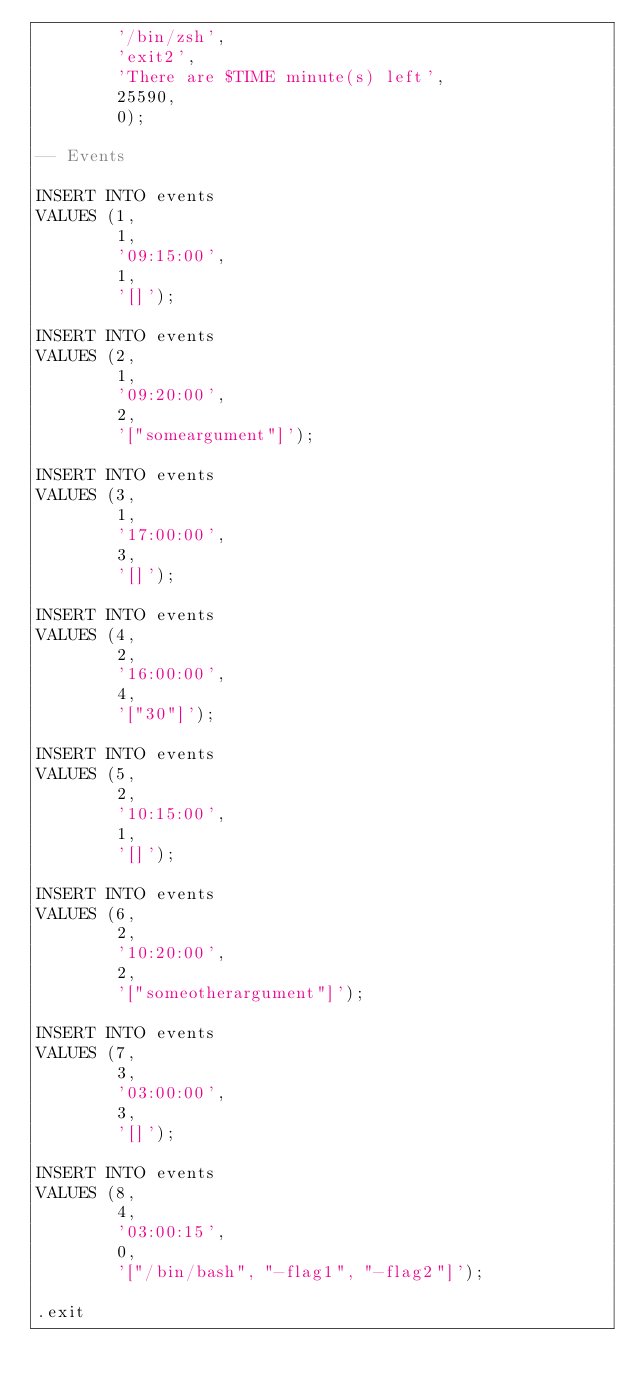Convert code to text. <code><loc_0><loc_0><loc_500><loc_500><_SQL_>        '/bin/zsh',
        'exit2',
        'There are $TIME minute(s) left',
        25590,
        0);

-- Events

INSERT INTO events
VALUES (1,
        1,
        '09:15:00',
        1,
        '[]');

INSERT INTO events
VALUES (2,
        1,
        '09:20:00',
        2,
        '["someargument"]');

INSERT INTO events
VALUES (3,
        1,
        '17:00:00',
        3,
        '[]');

INSERT INTO events
VALUES (4,
        2,
        '16:00:00',
        4,
        '["30"]');

INSERT INTO events
VALUES (5,
        2,
        '10:15:00',
        1,
        '[]');

INSERT INTO events
VALUES (6,
        2,
        '10:20:00',
        2,
        '["someotherargument"]');

INSERT INTO events
VALUES (7,
        3,
        '03:00:00',
        3,
        '[]');

INSERT INTO events
VALUES (8,
        4,
        '03:00:15',
        0,
        '["/bin/bash", "-flag1", "-flag2"]');

.exit</code> 